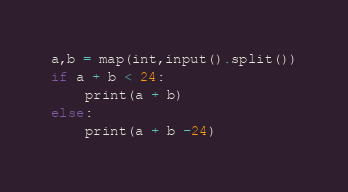<code> <loc_0><loc_0><loc_500><loc_500><_Python_>a,b = map(int,input().split())
if a + b < 24:
    print(a + b)
else:
    print(a + b -24)</code> 